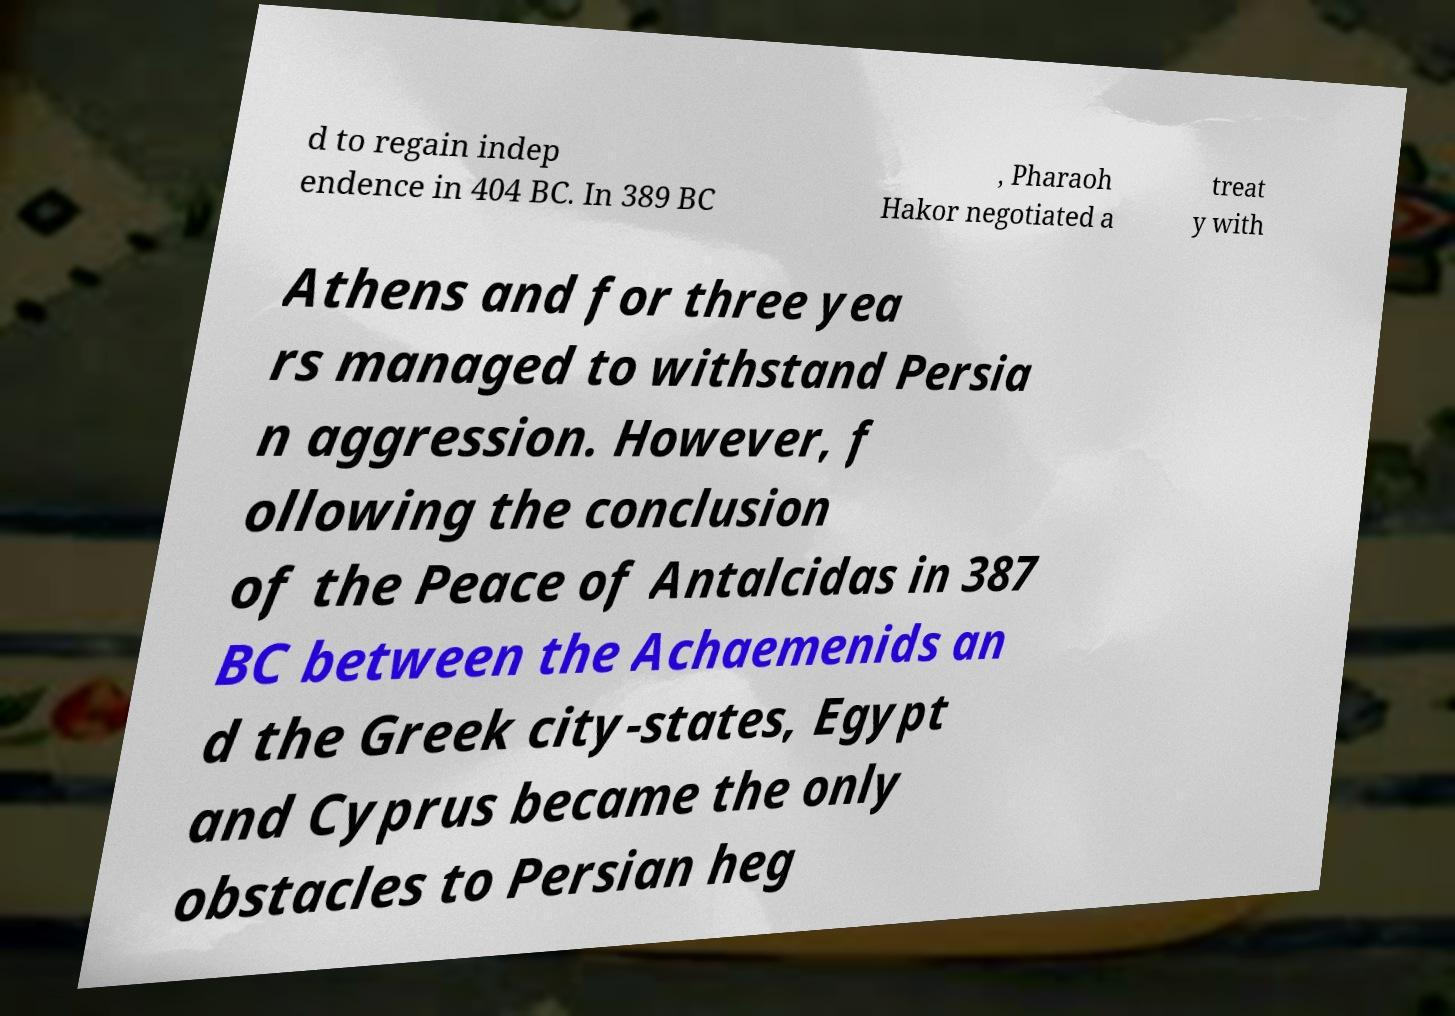Could you assist in decoding the text presented in this image and type it out clearly? d to regain indep endence in 404 BC. In 389 BC , Pharaoh Hakor negotiated a treat y with Athens and for three yea rs managed to withstand Persia n aggression. However, f ollowing the conclusion of the Peace of Antalcidas in 387 BC between the Achaemenids an d the Greek city-states, Egypt and Cyprus became the only obstacles to Persian heg 